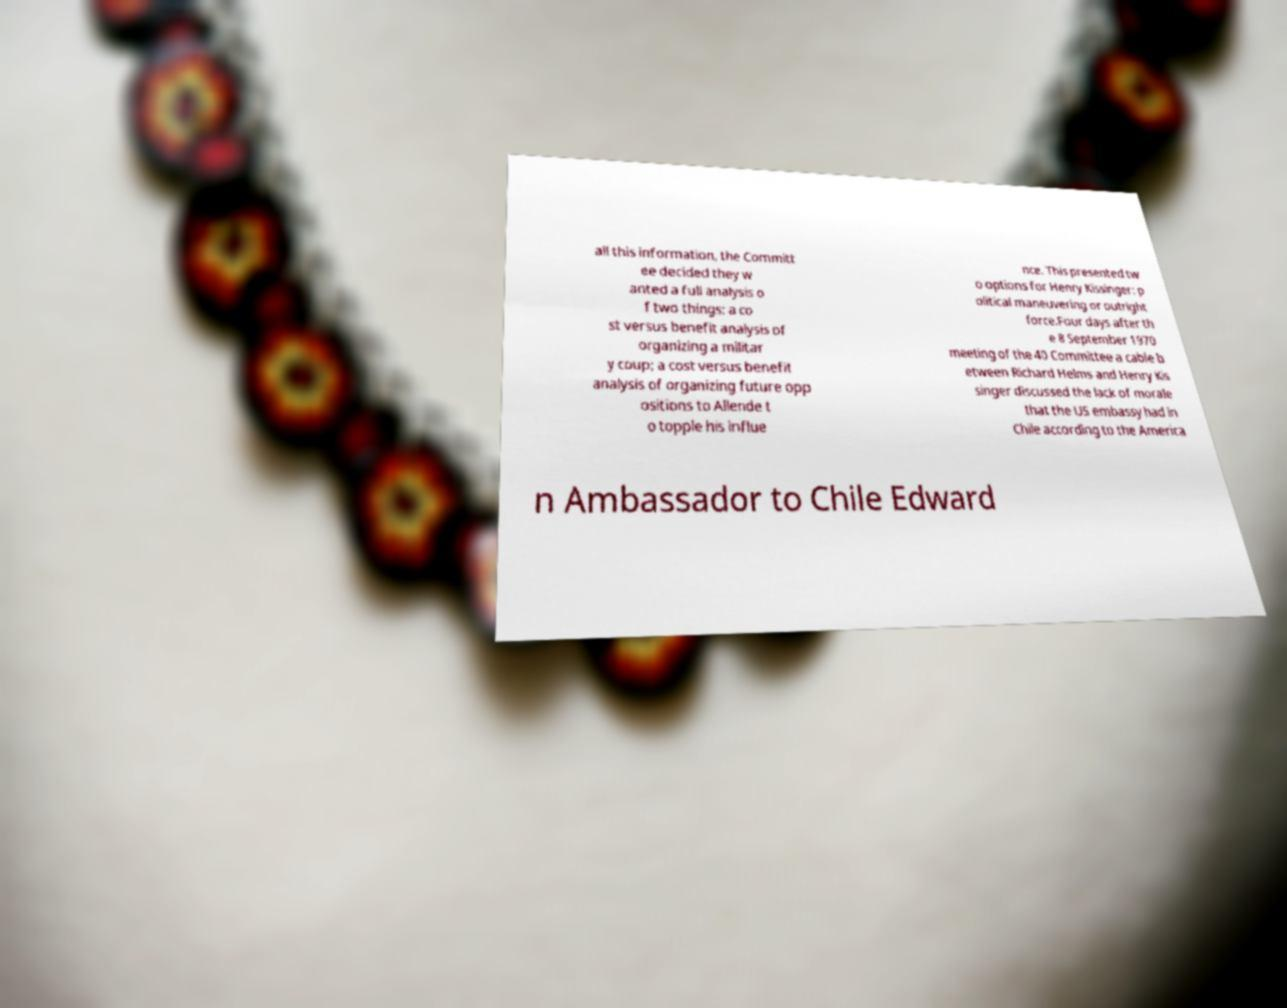For documentation purposes, I need the text within this image transcribed. Could you provide that? all this information, the Committ ee decided they w anted a full analysis o f two things: a co st versus benefit analysis of organizing a militar y coup; a cost versus benefit analysis of organizing future opp ositions to Allende t o topple his influe nce. This presented tw o options for Henry Kissinger: p olitical maneuvering or outright force.Four days after th e 8 September 1970 meeting of the 40 Committee a cable b etween Richard Helms and Henry Kis singer discussed the lack of morale that the US embassy had in Chile according to the America n Ambassador to Chile Edward 